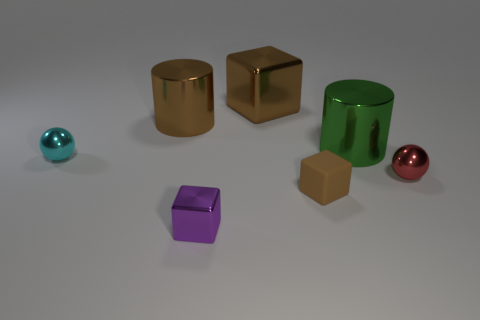Add 1 cyan metal objects. How many objects exist? 8 Subtract all cubes. How many objects are left? 4 Subtract all tiny gray things. Subtract all small purple blocks. How many objects are left? 6 Add 5 tiny shiny blocks. How many tiny shiny blocks are left? 6 Add 7 tiny red rubber things. How many tiny red rubber things exist? 7 Subtract 0 blue blocks. How many objects are left? 7 